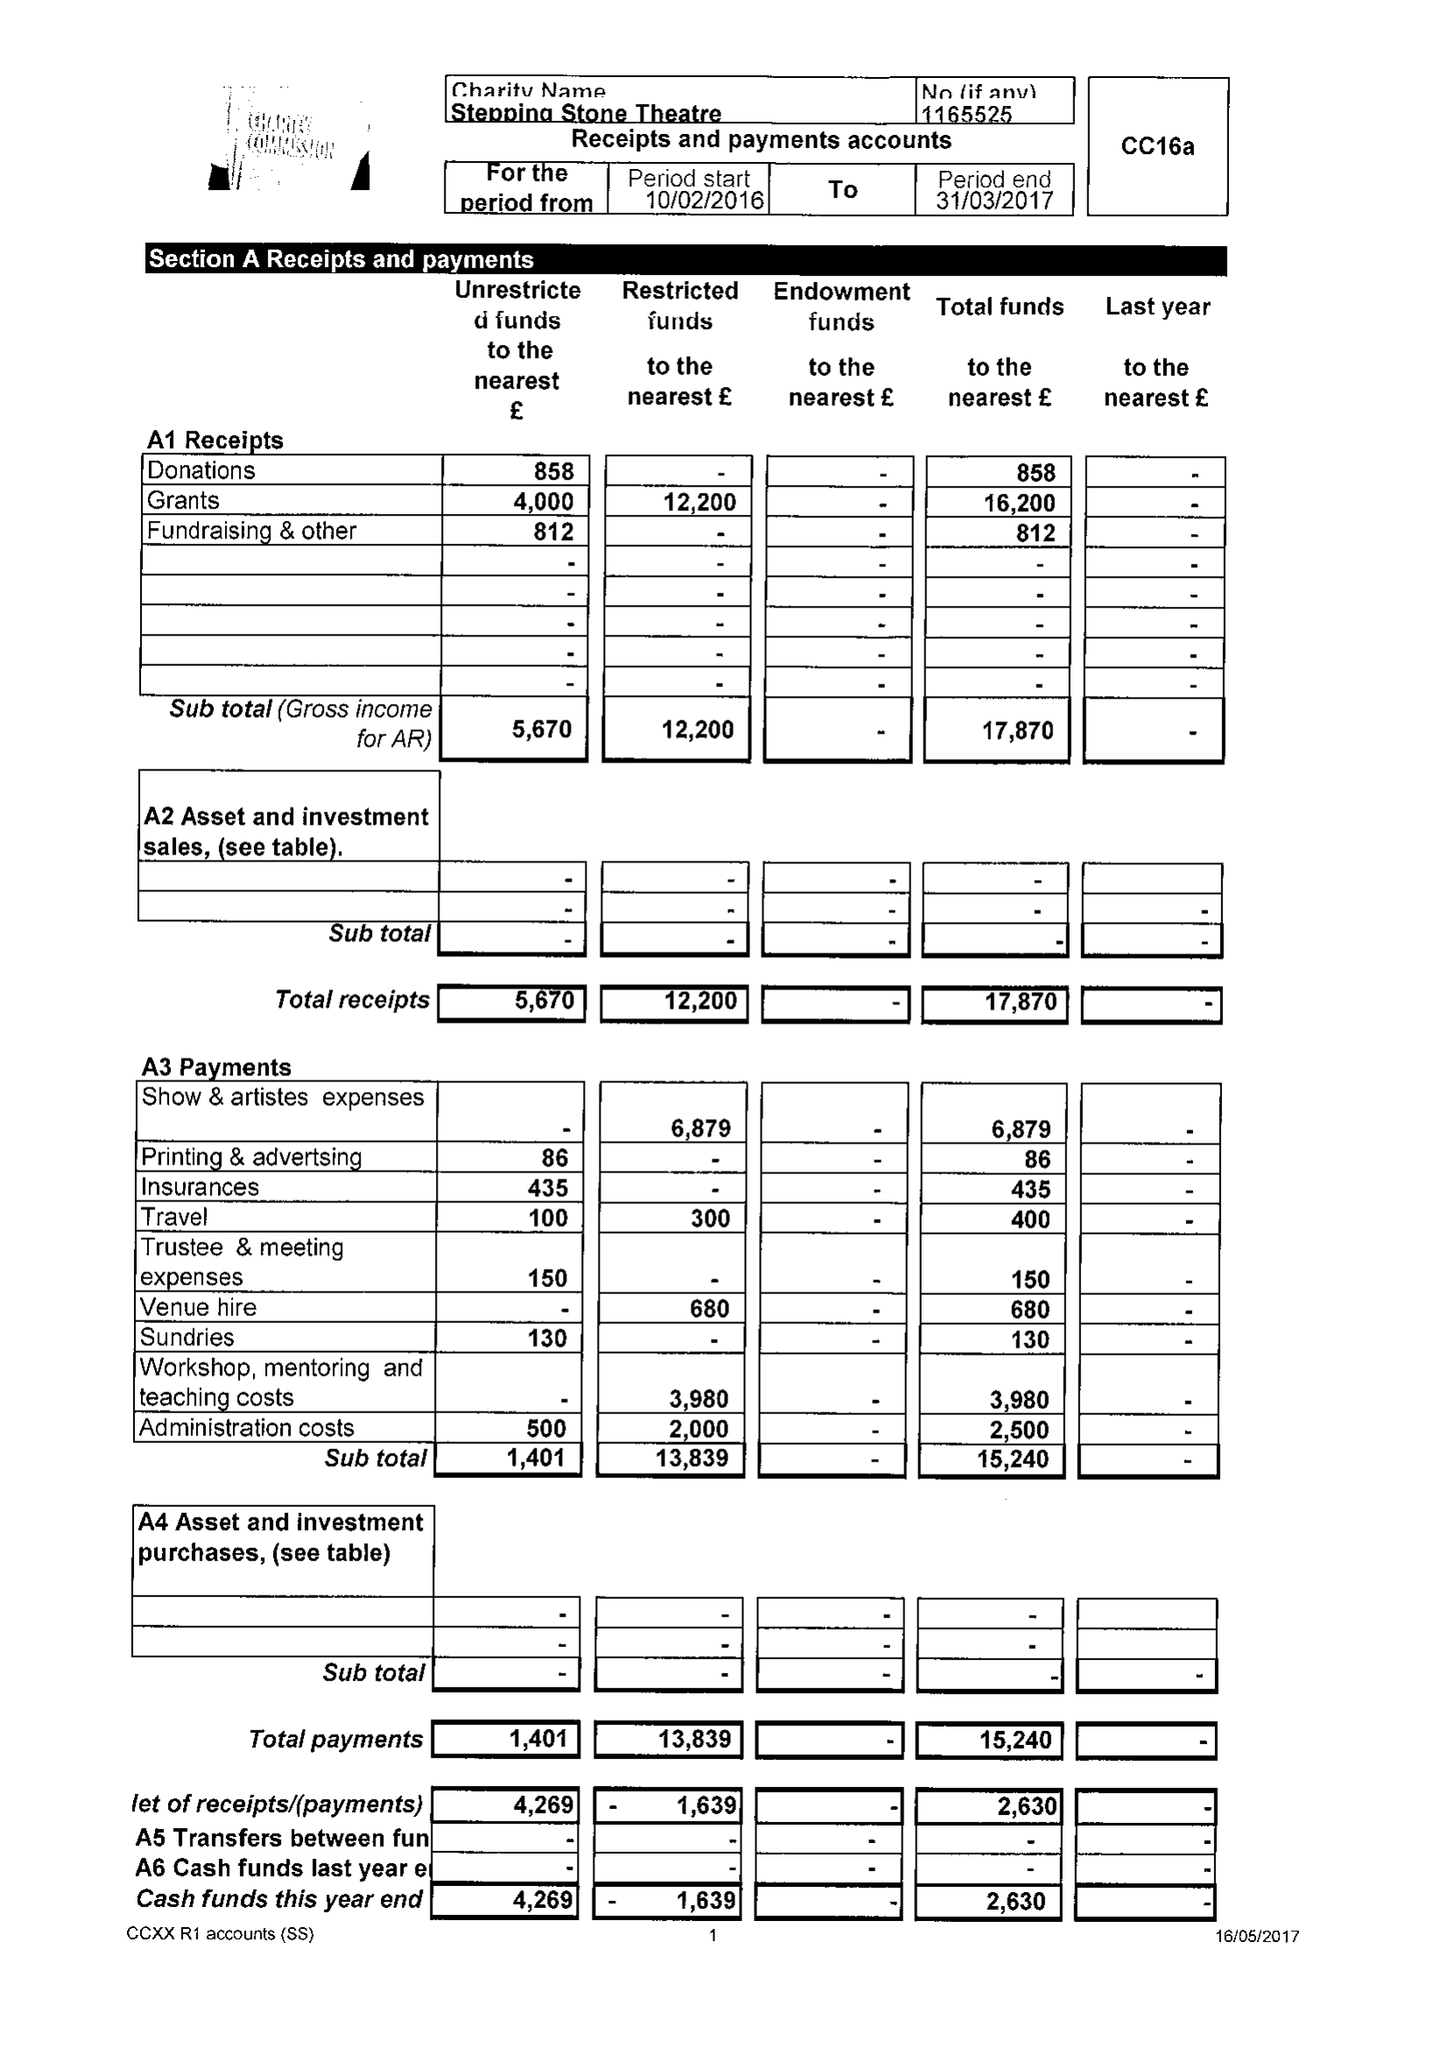What is the value for the report_date?
Answer the question using a single word or phrase. 2017-03-31 